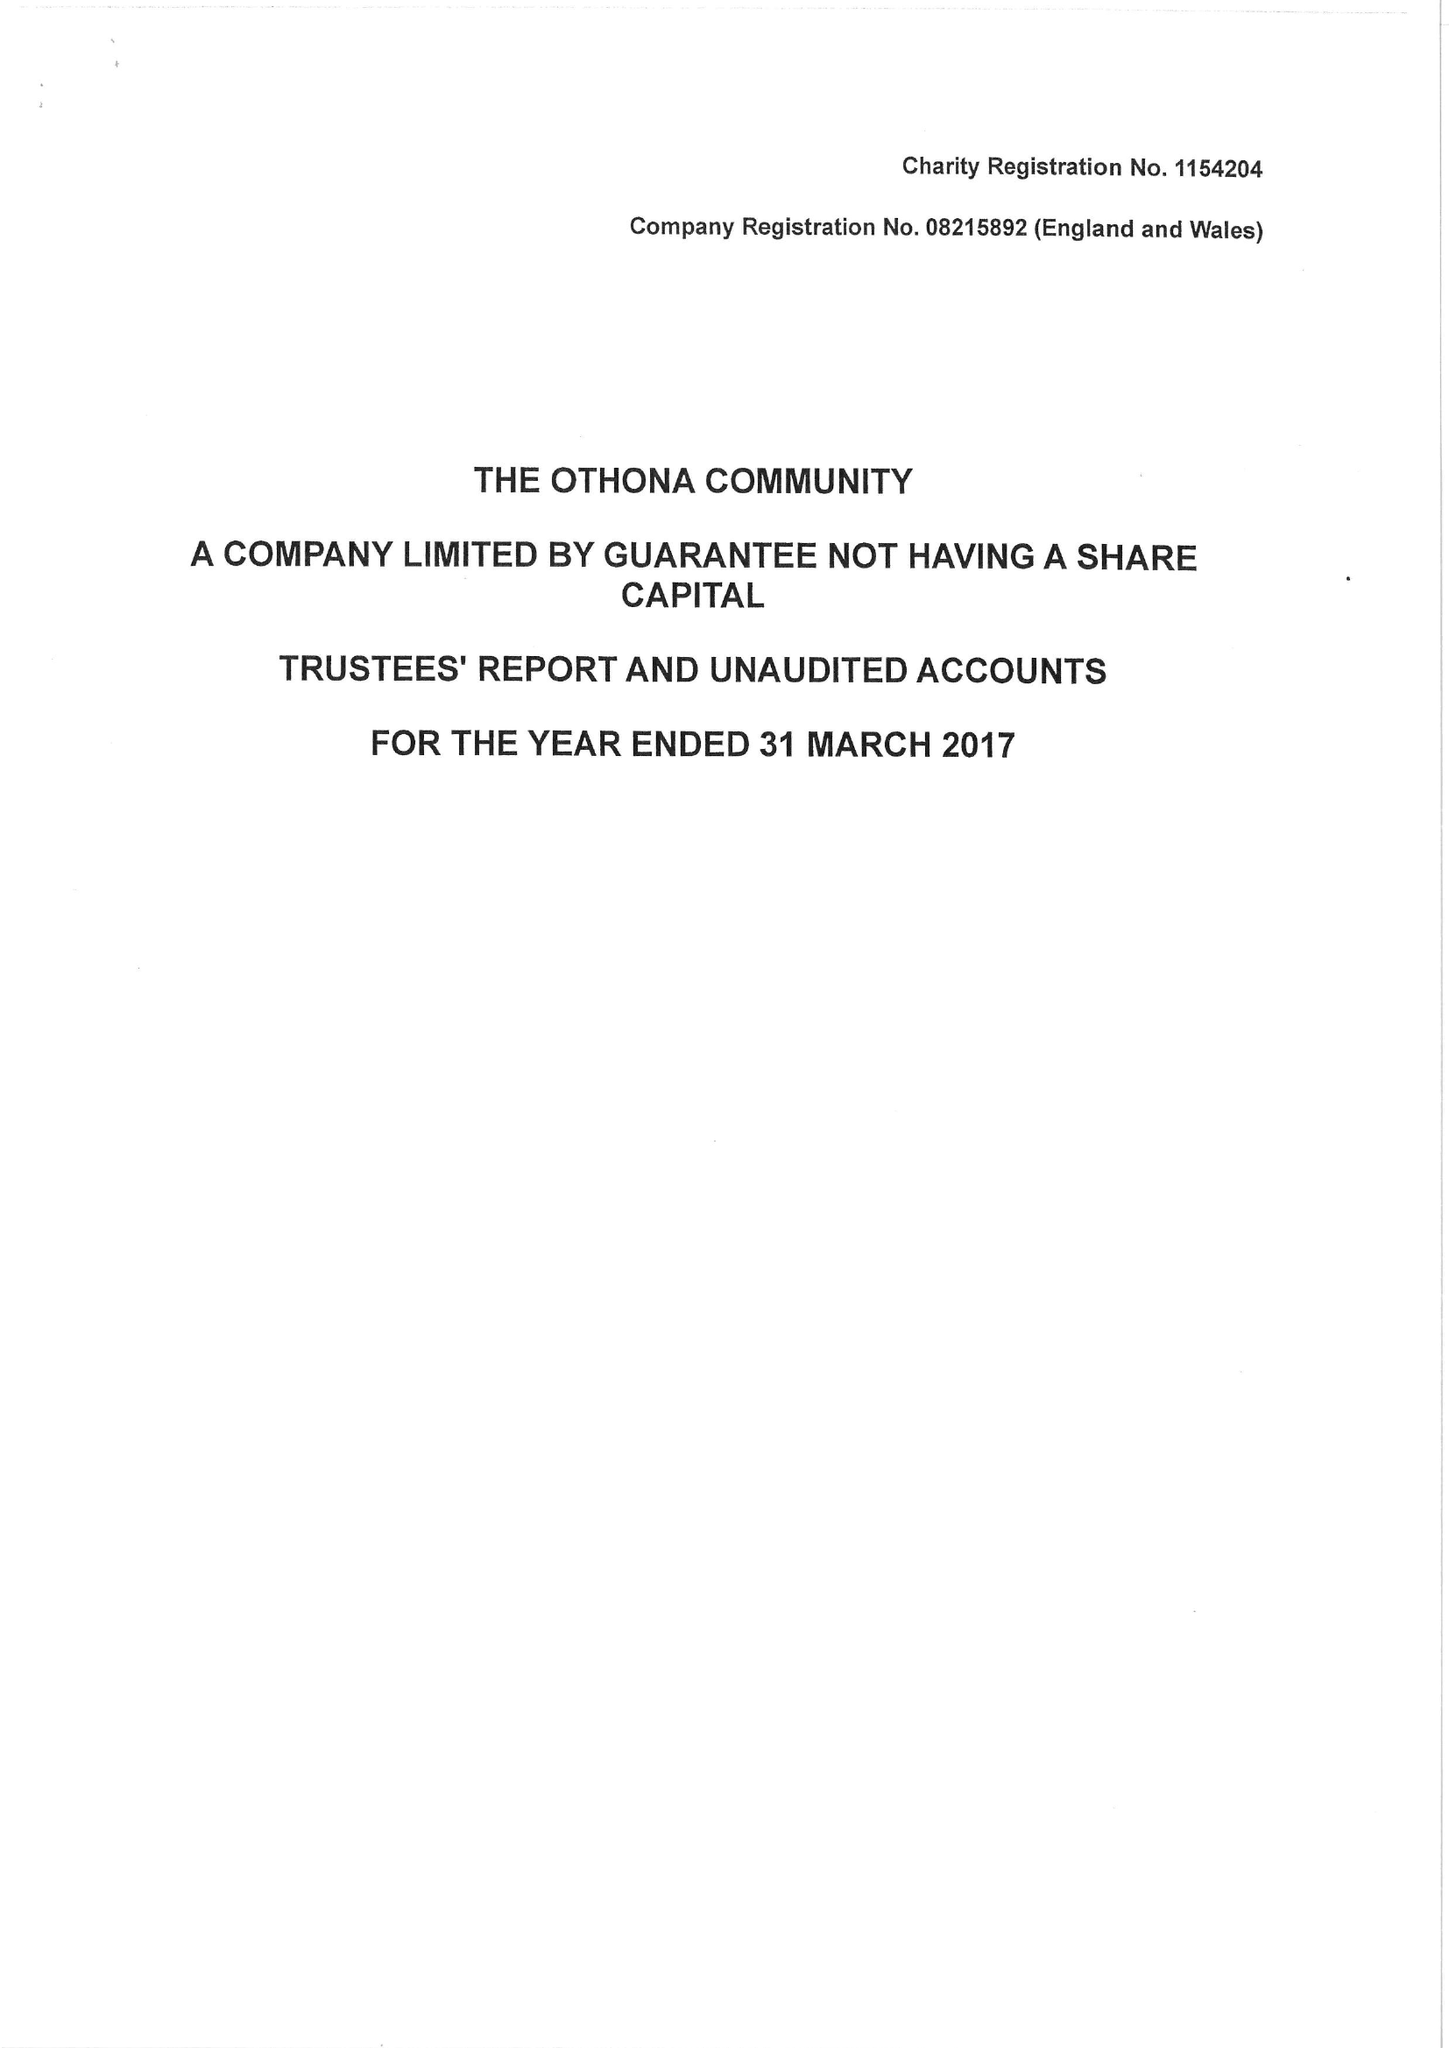What is the value for the charity_name?
Answer the question using a single word or phrase. The Othona Community 